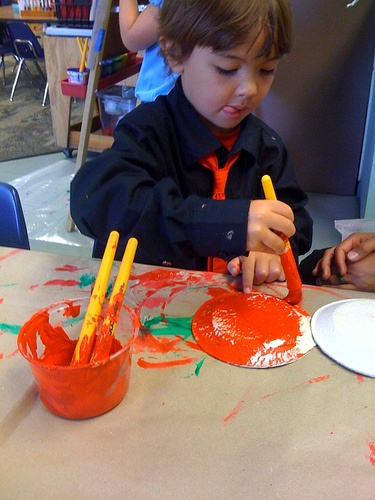Describe the objects in this image and their specific colors. I can see people in navy, black, maroon, and brown tones, chair in navy, black, and gray tones, bowl in navy, red, brown, and salmon tones, cup in navy, red, brown, and salmon tones, and people in navy, lightblue, gray, and purple tones in this image. 